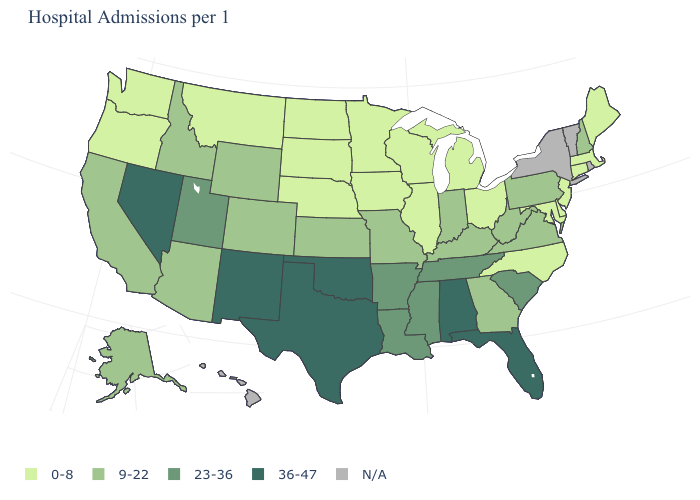Among the states that border Idaho , which have the lowest value?
Be succinct. Montana, Oregon, Washington. What is the value of Indiana?
Short answer required. 9-22. Which states hav the highest value in the MidWest?
Quick response, please. Indiana, Kansas, Missouri. What is the value of North Carolina?
Be succinct. 0-8. Which states hav the highest value in the West?
Be succinct. Nevada, New Mexico. Among the states that border New York , does Pennsylvania have the highest value?
Keep it brief. Yes. Among the states that border Colorado , which have the lowest value?
Keep it brief. Nebraska. Name the states that have a value in the range 0-8?
Quick response, please. Connecticut, Delaware, Illinois, Iowa, Maine, Maryland, Massachusetts, Michigan, Minnesota, Montana, Nebraska, New Jersey, North Carolina, North Dakota, Ohio, Oregon, South Dakota, Washington, Wisconsin. What is the value of Montana?
Give a very brief answer. 0-8. Which states hav the highest value in the West?
Keep it brief. Nevada, New Mexico. Among the states that border Minnesota , which have the lowest value?
Quick response, please. Iowa, North Dakota, South Dakota, Wisconsin. Does the first symbol in the legend represent the smallest category?
Give a very brief answer. Yes. What is the value of Connecticut?
Answer briefly. 0-8. 